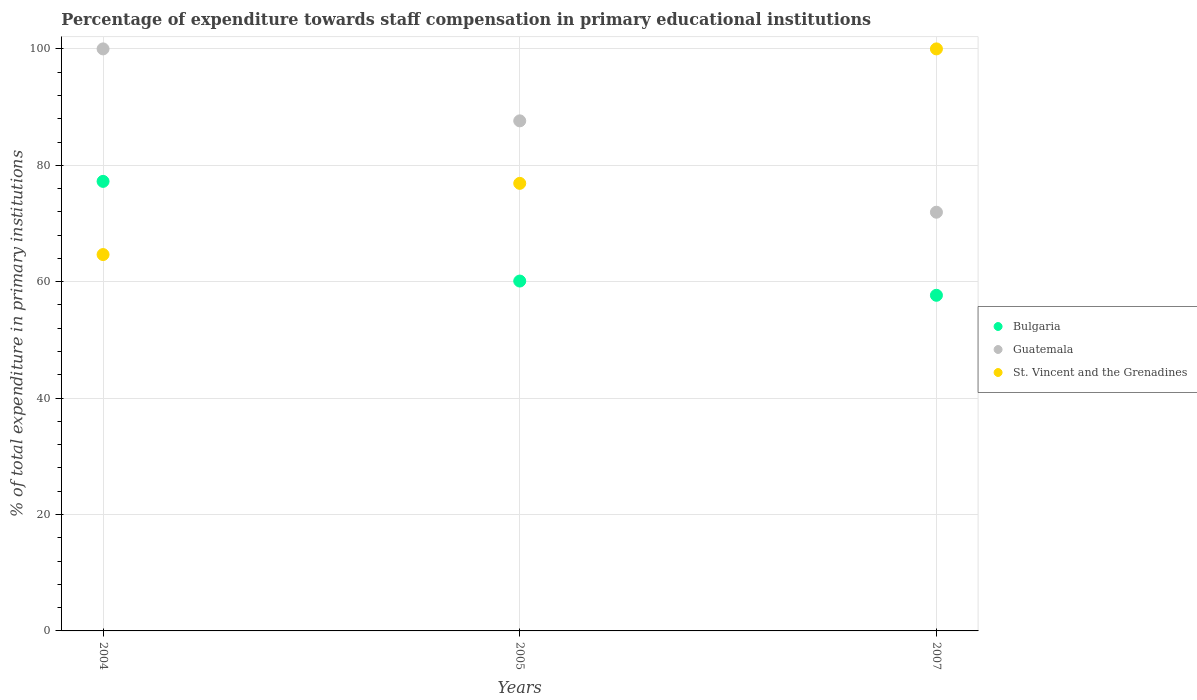Is the number of dotlines equal to the number of legend labels?
Provide a succinct answer. Yes. What is the percentage of expenditure towards staff compensation in Bulgaria in 2004?
Your answer should be very brief. 77.24. Across all years, what is the maximum percentage of expenditure towards staff compensation in Bulgaria?
Make the answer very short. 77.24. Across all years, what is the minimum percentage of expenditure towards staff compensation in Bulgaria?
Your answer should be very brief. 57.67. What is the total percentage of expenditure towards staff compensation in Bulgaria in the graph?
Provide a short and direct response. 195.02. What is the difference between the percentage of expenditure towards staff compensation in St. Vincent and the Grenadines in 2004 and that in 2005?
Make the answer very short. -12.23. What is the difference between the percentage of expenditure towards staff compensation in St. Vincent and the Grenadines in 2004 and the percentage of expenditure towards staff compensation in Guatemala in 2005?
Keep it short and to the point. -22.97. What is the average percentage of expenditure towards staff compensation in Guatemala per year?
Ensure brevity in your answer.  86.53. In the year 2004, what is the difference between the percentage of expenditure towards staff compensation in St. Vincent and the Grenadines and percentage of expenditure towards staff compensation in Guatemala?
Ensure brevity in your answer.  -35.34. In how many years, is the percentage of expenditure towards staff compensation in Guatemala greater than 20 %?
Make the answer very short. 3. What is the ratio of the percentage of expenditure towards staff compensation in Bulgaria in 2005 to that in 2007?
Offer a terse response. 1.04. Is the percentage of expenditure towards staff compensation in St. Vincent and the Grenadines in 2004 less than that in 2007?
Ensure brevity in your answer.  Yes. What is the difference between the highest and the second highest percentage of expenditure towards staff compensation in St. Vincent and the Grenadines?
Your answer should be compact. 23.1. What is the difference between the highest and the lowest percentage of expenditure towards staff compensation in St. Vincent and the Grenadines?
Your response must be concise. 35.34. Is the sum of the percentage of expenditure towards staff compensation in Guatemala in 2004 and 2005 greater than the maximum percentage of expenditure towards staff compensation in Bulgaria across all years?
Offer a terse response. Yes. Is it the case that in every year, the sum of the percentage of expenditure towards staff compensation in Bulgaria and percentage of expenditure towards staff compensation in Guatemala  is greater than the percentage of expenditure towards staff compensation in St. Vincent and the Grenadines?
Provide a succinct answer. Yes. Is the percentage of expenditure towards staff compensation in St. Vincent and the Grenadines strictly greater than the percentage of expenditure towards staff compensation in Guatemala over the years?
Your response must be concise. No. Is the percentage of expenditure towards staff compensation in Bulgaria strictly less than the percentage of expenditure towards staff compensation in St. Vincent and the Grenadines over the years?
Your answer should be very brief. No. How many dotlines are there?
Your answer should be very brief. 3. What is the difference between two consecutive major ticks on the Y-axis?
Offer a very short reply. 20. Does the graph contain any zero values?
Provide a succinct answer. No. Where does the legend appear in the graph?
Provide a succinct answer. Center right. What is the title of the graph?
Your answer should be compact. Percentage of expenditure towards staff compensation in primary educational institutions. What is the label or title of the X-axis?
Offer a terse response. Years. What is the label or title of the Y-axis?
Your answer should be very brief. % of total expenditure in primary institutions. What is the % of total expenditure in primary institutions in Bulgaria in 2004?
Provide a succinct answer. 77.24. What is the % of total expenditure in primary institutions of St. Vincent and the Grenadines in 2004?
Your response must be concise. 64.66. What is the % of total expenditure in primary institutions in Bulgaria in 2005?
Offer a terse response. 60.11. What is the % of total expenditure in primary institutions of Guatemala in 2005?
Your response must be concise. 87.64. What is the % of total expenditure in primary institutions in St. Vincent and the Grenadines in 2005?
Ensure brevity in your answer.  76.9. What is the % of total expenditure in primary institutions of Bulgaria in 2007?
Ensure brevity in your answer.  57.67. What is the % of total expenditure in primary institutions of Guatemala in 2007?
Offer a terse response. 71.94. What is the % of total expenditure in primary institutions of St. Vincent and the Grenadines in 2007?
Offer a very short reply. 100. Across all years, what is the maximum % of total expenditure in primary institutions in Bulgaria?
Make the answer very short. 77.24. Across all years, what is the maximum % of total expenditure in primary institutions in Guatemala?
Give a very brief answer. 100. Across all years, what is the minimum % of total expenditure in primary institutions of Bulgaria?
Ensure brevity in your answer.  57.67. Across all years, what is the minimum % of total expenditure in primary institutions of Guatemala?
Your response must be concise. 71.94. Across all years, what is the minimum % of total expenditure in primary institutions of St. Vincent and the Grenadines?
Provide a short and direct response. 64.66. What is the total % of total expenditure in primary institutions in Bulgaria in the graph?
Your response must be concise. 195.02. What is the total % of total expenditure in primary institutions of Guatemala in the graph?
Your response must be concise. 259.58. What is the total % of total expenditure in primary institutions of St. Vincent and the Grenadines in the graph?
Your answer should be very brief. 241.56. What is the difference between the % of total expenditure in primary institutions of Bulgaria in 2004 and that in 2005?
Offer a terse response. 17.12. What is the difference between the % of total expenditure in primary institutions in Guatemala in 2004 and that in 2005?
Provide a short and direct response. 12.36. What is the difference between the % of total expenditure in primary institutions of St. Vincent and the Grenadines in 2004 and that in 2005?
Offer a terse response. -12.23. What is the difference between the % of total expenditure in primary institutions in Bulgaria in 2004 and that in 2007?
Ensure brevity in your answer.  19.57. What is the difference between the % of total expenditure in primary institutions in Guatemala in 2004 and that in 2007?
Your response must be concise. 28.06. What is the difference between the % of total expenditure in primary institutions of St. Vincent and the Grenadines in 2004 and that in 2007?
Your answer should be compact. -35.34. What is the difference between the % of total expenditure in primary institutions in Bulgaria in 2005 and that in 2007?
Offer a terse response. 2.45. What is the difference between the % of total expenditure in primary institutions in Guatemala in 2005 and that in 2007?
Keep it short and to the point. 15.7. What is the difference between the % of total expenditure in primary institutions in St. Vincent and the Grenadines in 2005 and that in 2007?
Give a very brief answer. -23.1. What is the difference between the % of total expenditure in primary institutions in Bulgaria in 2004 and the % of total expenditure in primary institutions in Guatemala in 2005?
Keep it short and to the point. -10.4. What is the difference between the % of total expenditure in primary institutions of Bulgaria in 2004 and the % of total expenditure in primary institutions of St. Vincent and the Grenadines in 2005?
Provide a succinct answer. 0.34. What is the difference between the % of total expenditure in primary institutions of Guatemala in 2004 and the % of total expenditure in primary institutions of St. Vincent and the Grenadines in 2005?
Your response must be concise. 23.1. What is the difference between the % of total expenditure in primary institutions in Bulgaria in 2004 and the % of total expenditure in primary institutions in Guatemala in 2007?
Offer a terse response. 5.3. What is the difference between the % of total expenditure in primary institutions of Bulgaria in 2004 and the % of total expenditure in primary institutions of St. Vincent and the Grenadines in 2007?
Offer a terse response. -22.76. What is the difference between the % of total expenditure in primary institutions of Bulgaria in 2005 and the % of total expenditure in primary institutions of Guatemala in 2007?
Make the answer very short. -11.83. What is the difference between the % of total expenditure in primary institutions of Bulgaria in 2005 and the % of total expenditure in primary institutions of St. Vincent and the Grenadines in 2007?
Your response must be concise. -39.89. What is the difference between the % of total expenditure in primary institutions of Guatemala in 2005 and the % of total expenditure in primary institutions of St. Vincent and the Grenadines in 2007?
Provide a succinct answer. -12.36. What is the average % of total expenditure in primary institutions in Bulgaria per year?
Provide a short and direct response. 65.01. What is the average % of total expenditure in primary institutions of Guatemala per year?
Provide a short and direct response. 86.53. What is the average % of total expenditure in primary institutions in St. Vincent and the Grenadines per year?
Offer a very short reply. 80.52. In the year 2004, what is the difference between the % of total expenditure in primary institutions of Bulgaria and % of total expenditure in primary institutions of Guatemala?
Provide a short and direct response. -22.76. In the year 2004, what is the difference between the % of total expenditure in primary institutions of Bulgaria and % of total expenditure in primary institutions of St. Vincent and the Grenadines?
Your response must be concise. 12.57. In the year 2004, what is the difference between the % of total expenditure in primary institutions in Guatemala and % of total expenditure in primary institutions in St. Vincent and the Grenadines?
Keep it short and to the point. 35.34. In the year 2005, what is the difference between the % of total expenditure in primary institutions in Bulgaria and % of total expenditure in primary institutions in Guatemala?
Your response must be concise. -27.52. In the year 2005, what is the difference between the % of total expenditure in primary institutions of Bulgaria and % of total expenditure in primary institutions of St. Vincent and the Grenadines?
Your answer should be very brief. -16.78. In the year 2005, what is the difference between the % of total expenditure in primary institutions in Guatemala and % of total expenditure in primary institutions in St. Vincent and the Grenadines?
Your response must be concise. 10.74. In the year 2007, what is the difference between the % of total expenditure in primary institutions in Bulgaria and % of total expenditure in primary institutions in Guatemala?
Make the answer very short. -14.27. In the year 2007, what is the difference between the % of total expenditure in primary institutions in Bulgaria and % of total expenditure in primary institutions in St. Vincent and the Grenadines?
Offer a terse response. -42.33. In the year 2007, what is the difference between the % of total expenditure in primary institutions of Guatemala and % of total expenditure in primary institutions of St. Vincent and the Grenadines?
Ensure brevity in your answer.  -28.06. What is the ratio of the % of total expenditure in primary institutions in Bulgaria in 2004 to that in 2005?
Ensure brevity in your answer.  1.28. What is the ratio of the % of total expenditure in primary institutions in Guatemala in 2004 to that in 2005?
Ensure brevity in your answer.  1.14. What is the ratio of the % of total expenditure in primary institutions in St. Vincent and the Grenadines in 2004 to that in 2005?
Your answer should be compact. 0.84. What is the ratio of the % of total expenditure in primary institutions of Bulgaria in 2004 to that in 2007?
Your response must be concise. 1.34. What is the ratio of the % of total expenditure in primary institutions in Guatemala in 2004 to that in 2007?
Your answer should be compact. 1.39. What is the ratio of the % of total expenditure in primary institutions of St. Vincent and the Grenadines in 2004 to that in 2007?
Provide a succinct answer. 0.65. What is the ratio of the % of total expenditure in primary institutions of Bulgaria in 2005 to that in 2007?
Your answer should be very brief. 1.04. What is the ratio of the % of total expenditure in primary institutions in Guatemala in 2005 to that in 2007?
Offer a terse response. 1.22. What is the ratio of the % of total expenditure in primary institutions in St. Vincent and the Grenadines in 2005 to that in 2007?
Ensure brevity in your answer.  0.77. What is the difference between the highest and the second highest % of total expenditure in primary institutions in Bulgaria?
Your answer should be compact. 17.12. What is the difference between the highest and the second highest % of total expenditure in primary institutions of Guatemala?
Keep it short and to the point. 12.36. What is the difference between the highest and the second highest % of total expenditure in primary institutions in St. Vincent and the Grenadines?
Offer a terse response. 23.1. What is the difference between the highest and the lowest % of total expenditure in primary institutions of Bulgaria?
Your response must be concise. 19.57. What is the difference between the highest and the lowest % of total expenditure in primary institutions in Guatemala?
Offer a very short reply. 28.06. What is the difference between the highest and the lowest % of total expenditure in primary institutions of St. Vincent and the Grenadines?
Ensure brevity in your answer.  35.34. 